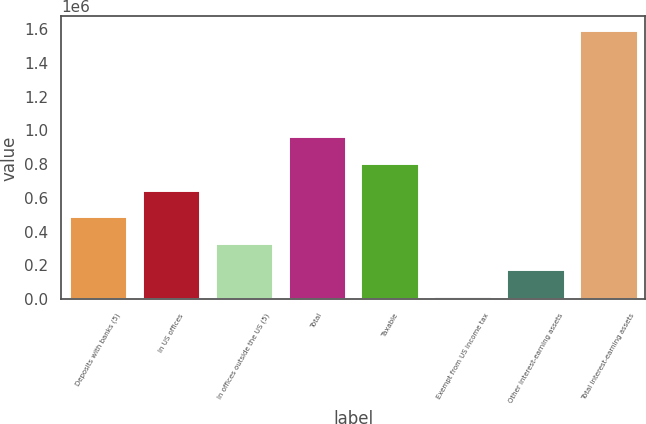<chart> <loc_0><loc_0><loc_500><loc_500><bar_chart><fcel>Deposits with banks (5)<fcel>In US offices<fcel>In offices outside the US (5)<fcel>Total<fcel>Taxable<fcel>Exempt from US income tax<fcel>Other interest-earning assets<fcel>Total interest-earning assets<nl><fcel>491581<fcel>649082<fcel>334080<fcel>964083<fcel>806582<fcel>19079<fcel>176580<fcel>1.59409e+06<nl></chart> 